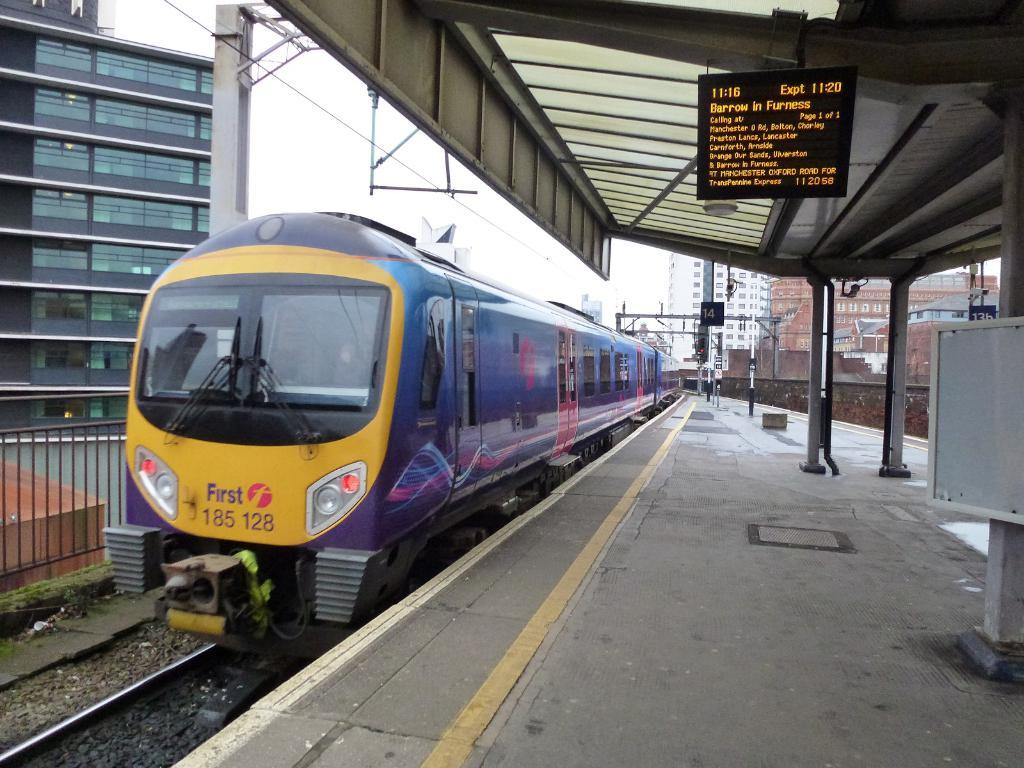What is the train number?
Make the answer very short. 185 128. What is the time in the upper left portion of the shot?
Provide a succinct answer. 11:16. 